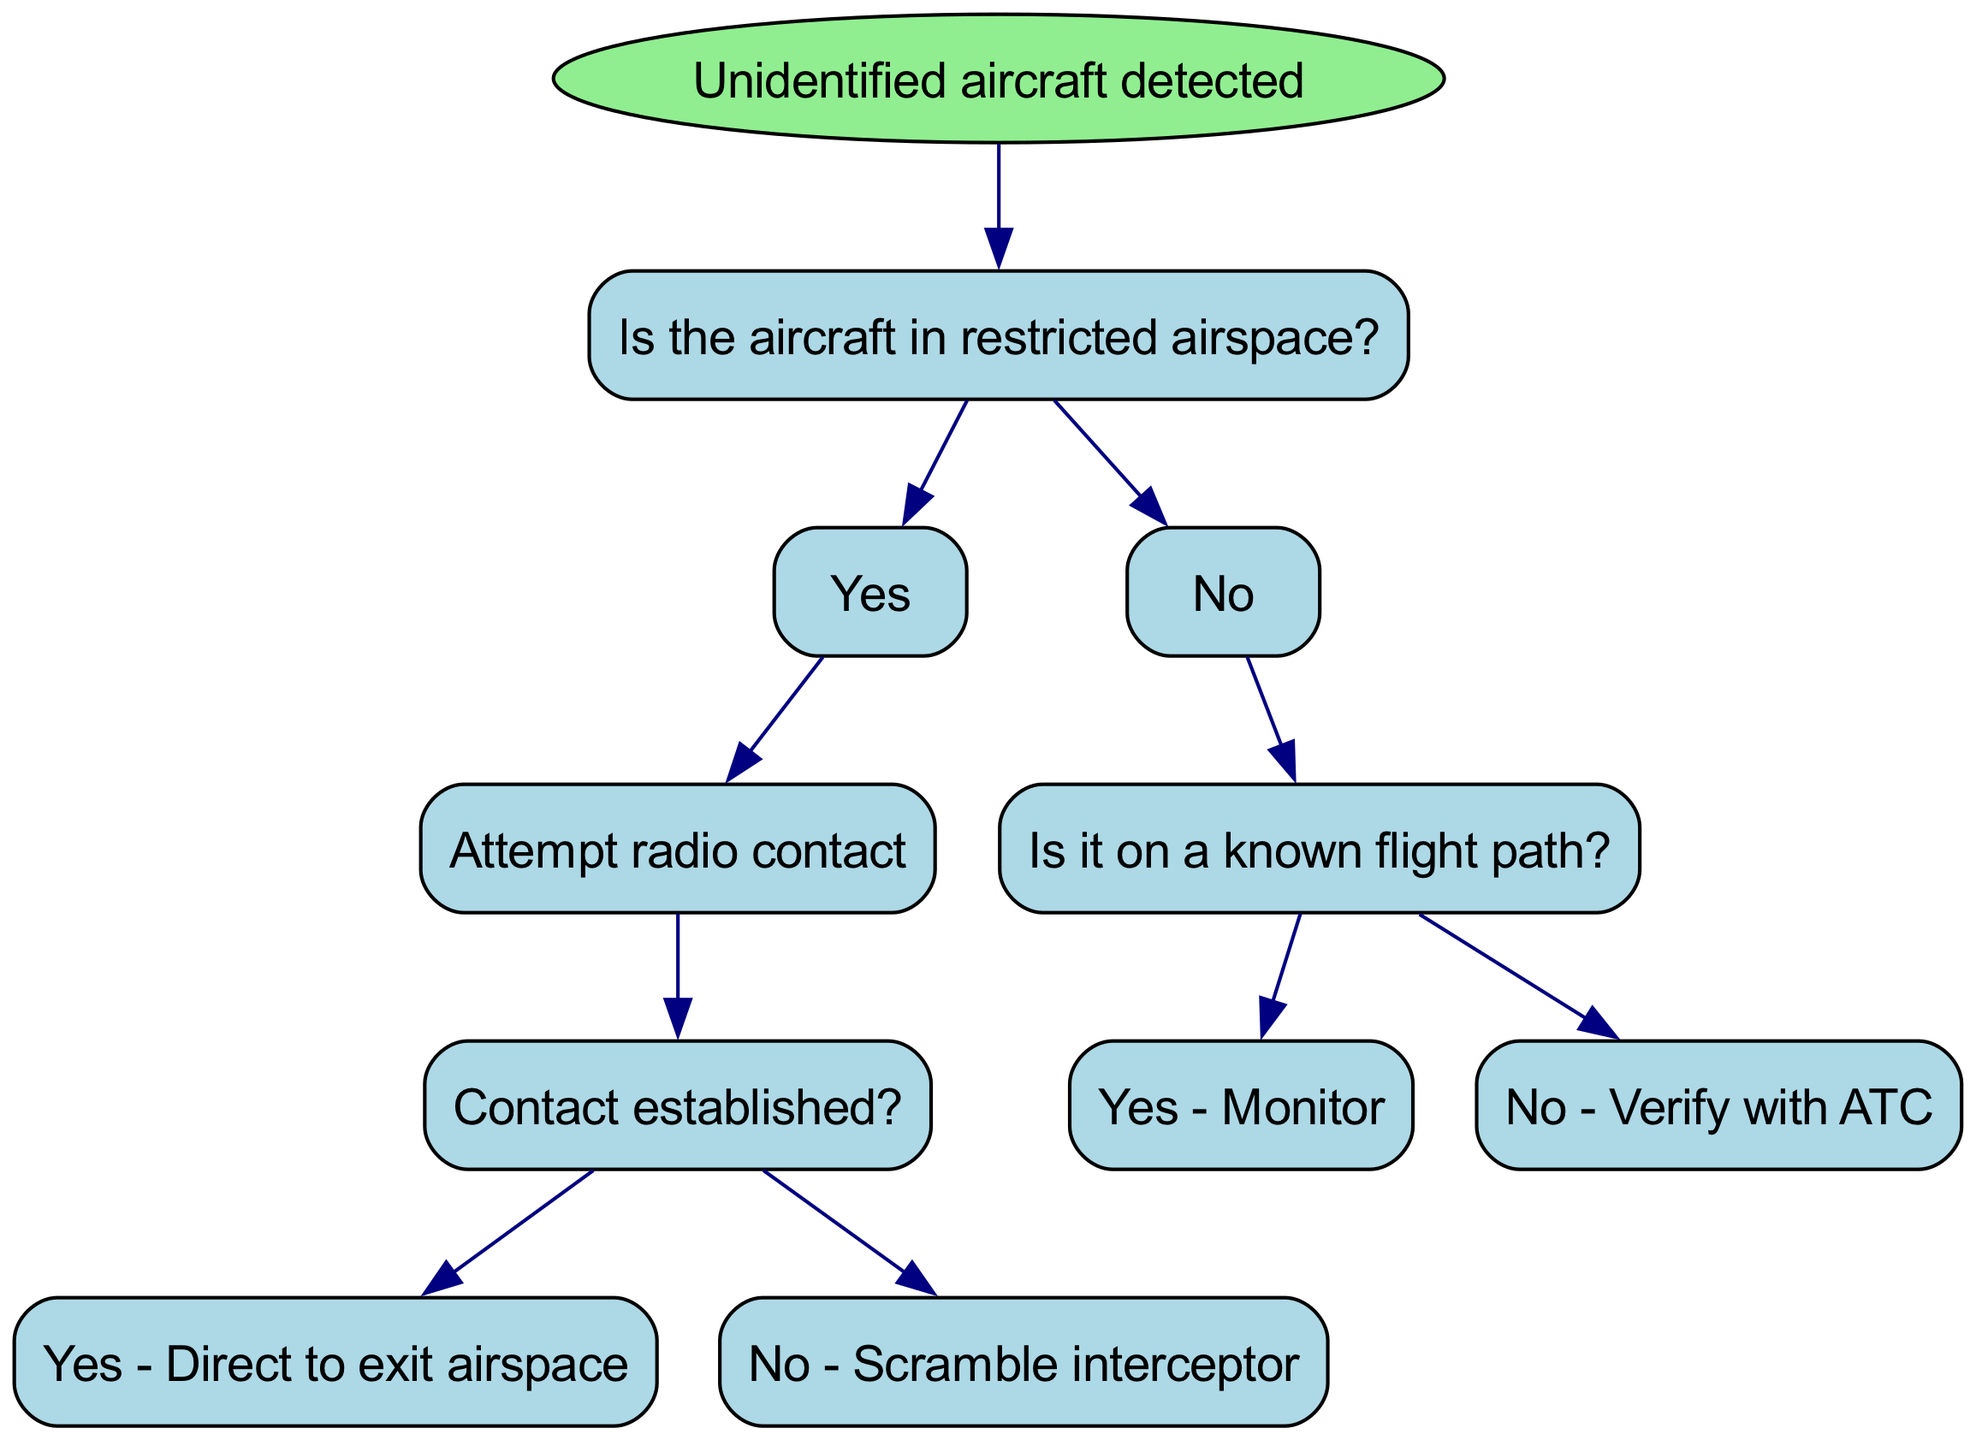What is the first decision to make when an unidentified aircraft is detected? The first decision is to determine if the aircraft is in restricted airspace, as indicated by the first node connected to the root.
Answer: Is the aircraft in restricted airspace? How many children does the node "Is the aircraft in restricted airspace?" have? The node has two children: one for "Yes" and one for "No." This means there are two possible pathways to follow based on the aircraft's location.
Answer: 2 What action is taken if contact is established after attempting radio contact with an aircraft in restricted airspace? If contact is established, the action taken according to the flow of the diagram is to direct the aircraft to exit the airspace. This is depicted in the respective child node following the node of "Contact established?"
Answer: Direct to exit airspace What do you do if the aircraft is not on a known flight path? If the aircraft is not on a known flight path, then you need to verify with ATC, as outlined in the decision tree following the "No" pathway after determining that the aircraft is out of restricted airspace.
Answer: Verify with ATC If an unidentified aircraft is detected and it is in restricted airspace, what is the first step? The first step is to attempt radio contact with the unidentified aircraft to gather more information and potentially establish communication before proceeding further.
Answer: Attempt radio contact What happens if radio contact attempt fails with an aircraft in restricted airspace? If the attempt to contact the aircraft fails, the action specified in the decision tree is to scramble an interceptor, indicating a more aggressive stance to deal with the unidentified aircraft.
Answer: Scramble interceptor How are the nodes organized after the initial detection of the unidentified aircraft? The nodes are organized in a branching structure, starting from the decision about restricted airspace, leading to further decisions based on the responses, culminating in specific actions depending on the outcome.
Answer: Branching structure What is the outcome if an unidentified aircraft is on a known flight path? If the aircraft is on a known flight path, the decision tree indicates that you should monitor the aircraft for any unusual behavior or further developments.
Answer: Monitor 